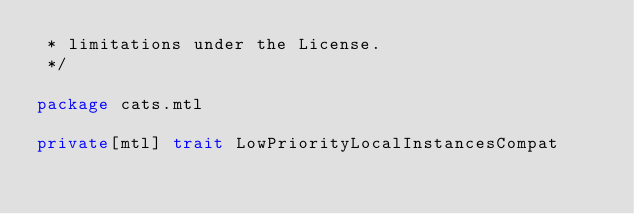<code> <loc_0><loc_0><loc_500><loc_500><_Scala_> * limitations under the License.
 */

package cats.mtl

private[mtl] trait LowPriorityLocalInstancesCompat
</code> 